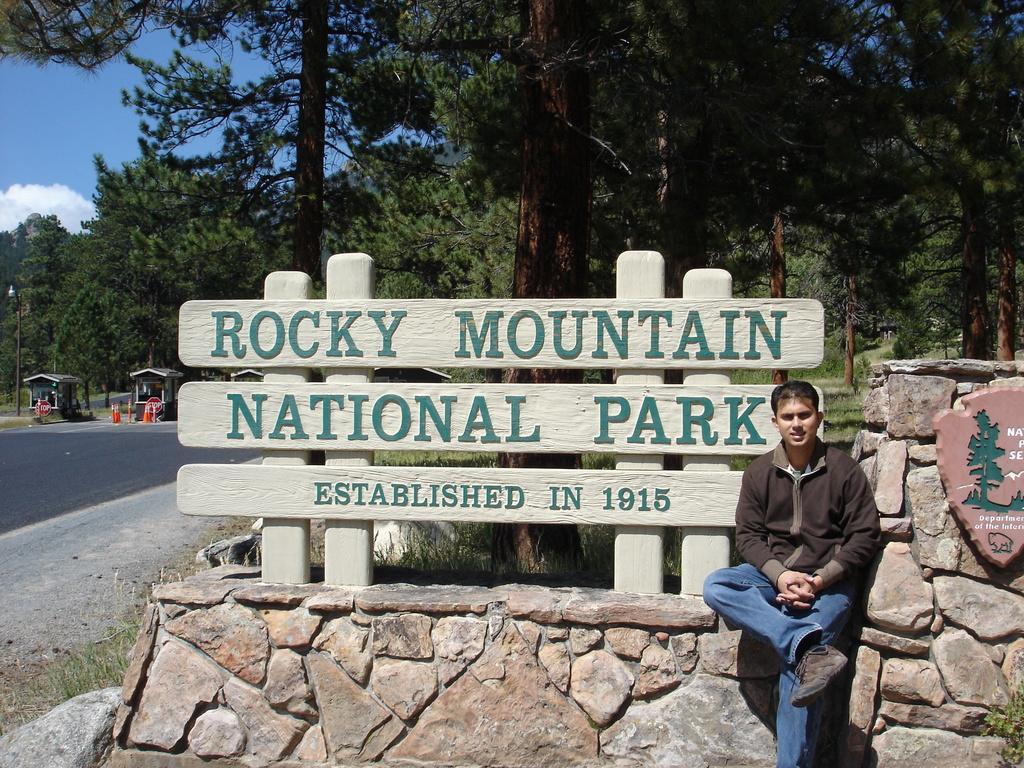Can you describe this image briefly? In this image I can see a man is sitting. I can see he is wearing a jacket, blue jeans, and a shoe. I can also see number of trees, few boards, cloud, the sky, few orange colored traffic cones and here on these boards I can see something is written. 